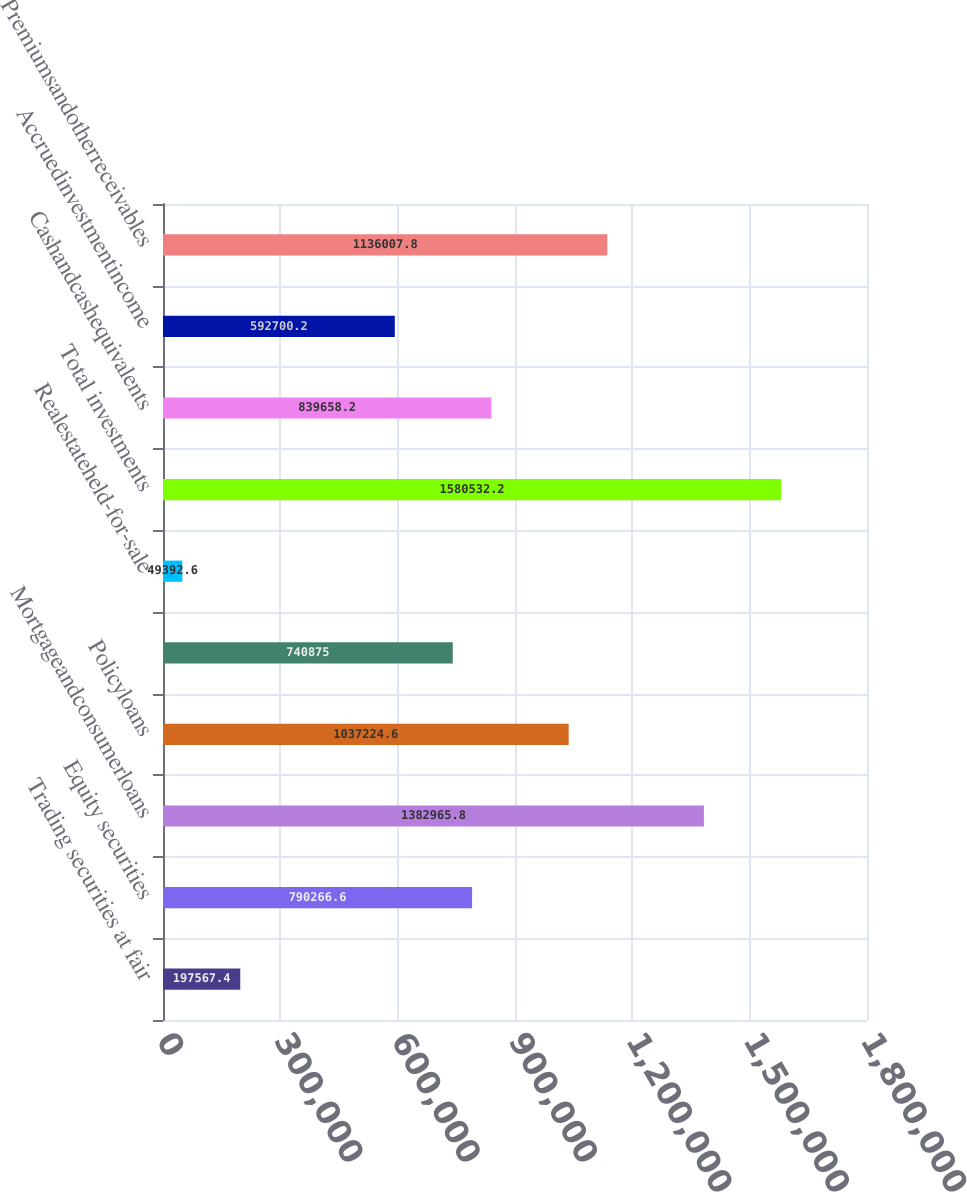Convert chart to OTSL. <chart><loc_0><loc_0><loc_500><loc_500><bar_chart><fcel>Trading securities at fair<fcel>Equity securities<fcel>Mortgageandconsumerloans<fcel>Policyloans<fcel>Unnamed: 4<fcel>Realestateheld-for-sale<fcel>Total investments<fcel>Cashandcashequivalents<fcel>Accruedinvestmentincome<fcel>Premiumsandotherreceivables<nl><fcel>197567<fcel>790267<fcel>1.38297e+06<fcel>1.03722e+06<fcel>740875<fcel>49392.6<fcel>1.58053e+06<fcel>839658<fcel>592700<fcel>1.13601e+06<nl></chart> 